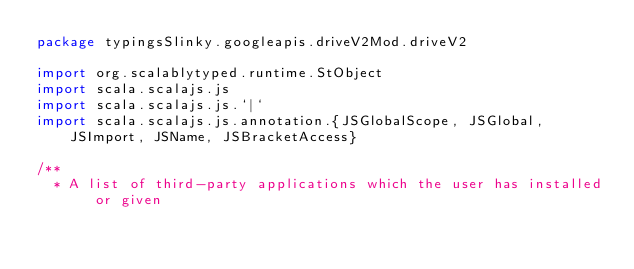<code> <loc_0><loc_0><loc_500><loc_500><_Scala_>package typingsSlinky.googleapis.driveV2Mod.driveV2

import org.scalablytyped.runtime.StObject
import scala.scalajs.js
import scala.scalajs.js.`|`
import scala.scalajs.js.annotation.{JSGlobalScope, JSGlobal, JSImport, JSName, JSBracketAccess}

/**
  * A list of third-party applications which the user has installed or given</code> 